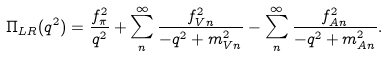<formula> <loc_0><loc_0><loc_500><loc_500>\Pi _ { L R } ( q ^ { 2 } ) = \frac { f _ { \pi } ^ { 2 } } { q ^ { 2 } } + \sum _ { n } ^ { \infty } \frac { f _ { V n } ^ { 2 } } { - q ^ { 2 } + m _ { V n } ^ { 2 } } - \sum _ { n } ^ { \infty } \frac { f _ { A n } ^ { 2 } } { - q ^ { 2 } + m _ { A n } ^ { 2 } } .</formula> 